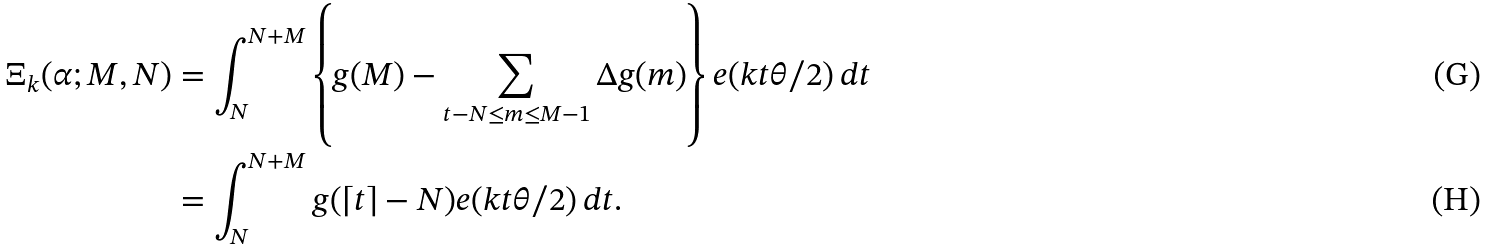Convert formula to latex. <formula><loc_0><loc_0><loc_500><loc_500>\Xi _ { k } ( \alpha ; M , N ) & = \int _ { N } ^ { N + M } \left \{ g ( M ) - \sum _ { t - N \leq m \leq M - 1 } \Delta g ( m ) \right \} e ( k t \theta / 2 ) \, d t \\ & = \int _ { N } ^ { N + M } g ( \lceil t \rceil - N ) e ( k t \theta / 2 ) \, d t .</formula> 